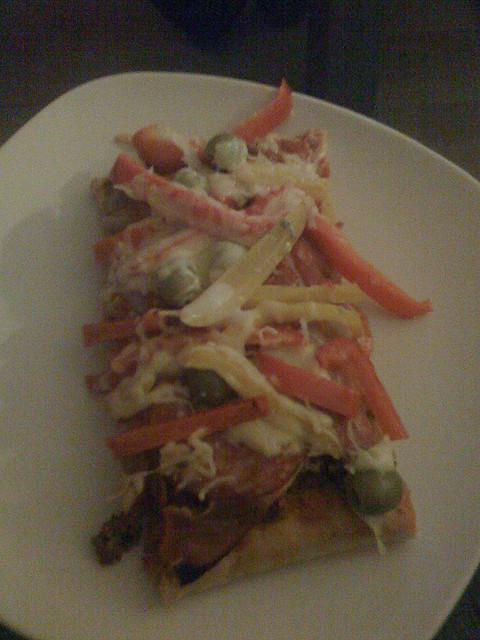How many carrots can be seen?
Give a very brief answer. 5. How many pizzas are there?
Give a very brief answer. 1. How many people are currently looking at the book?
Give a very brief answer. 0. 